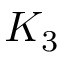Convert formula to latex. <formula><loc_0><loc_0><loc_500><loc_500>K _ { 3 }</formula> 